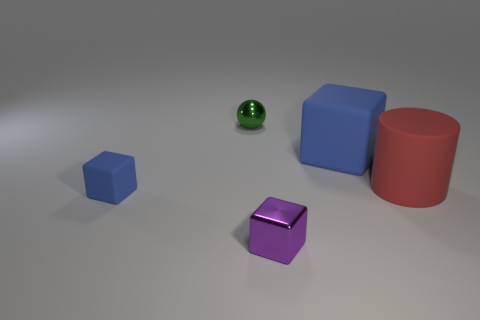Subtract all tiny purple shiny cubes. How many cubes are left? 2 Add 4 cyan metallic things. How many objects exist? 9 Subtract all purple cylinders. How many blue blocks are left? 2 Subtract all blue cubes. How many cubes are left? 1 Subtract all cubes. How many objects are left? 2 Subtract 1 cubes. How many cubes are left? 2 Add 2 green metal spheres. How many green metal spheres are left? 3 Add 2 big gray rubber cylinders. How many big gray rubber cylinders exist? 2 Subtract 1 green spheres. How many objects are left? 4 Subtract all red cubes. Subtract all purple cylinders. How many cubes are left? 3 